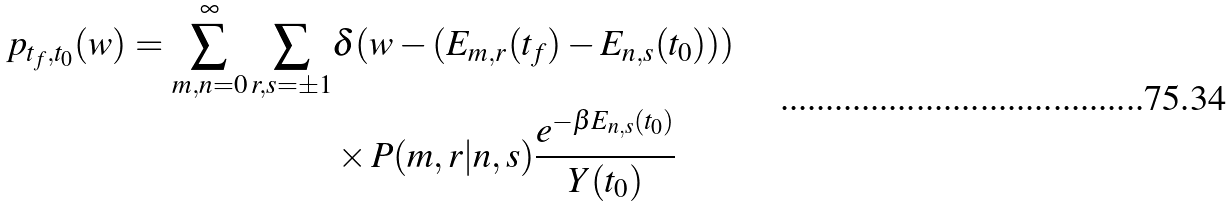Convert formula to latex. <formula><loc_0><loc_0><loc_500><loc_500>p _ { t _ { f } , t _ { 0 } } ( w ) = \sum _ { m , n = 0 } ^ { \infty } \sum _ { r , s = \pm 1 } & \delta ( w - ( E _ { m , r } ( t _ { f } ) - E _ { n , s } ( t _ { 0 } ) ) ) \\ & \times P ( m , r | n , s ) \frac { e ^ { - \beta E _ { n , s } ( t _ { 0 } ) } } { Y ( t _ { 0 } ) }</formula> 